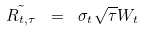Convert formula to latex. <formula><loc_0><loc_0><loc_500><loc_500>\tilde { R _ { t , \tau } } \ = \ \sigma _ { t } \sqrt { \tau } W _ { t }</formula> 